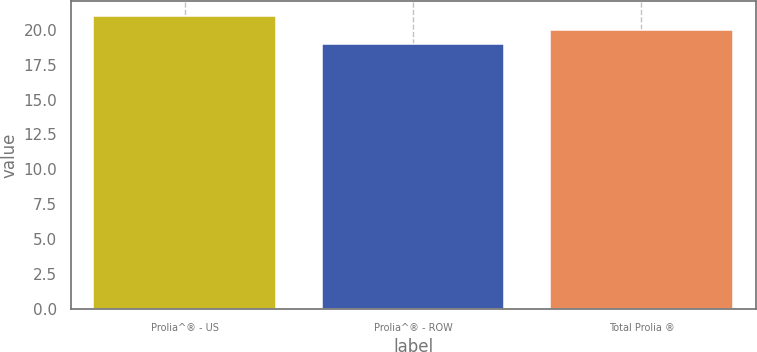Convert chart. <chart><loc_0><loc_0><loc_500><loc_500><bar_chart><fcel>Prolia^® - US<fcel>Prolia^® - ROW<fcel>Total Prolia ®<nl><fcel>21<fcel>19<fcel>20<nl></chart> 